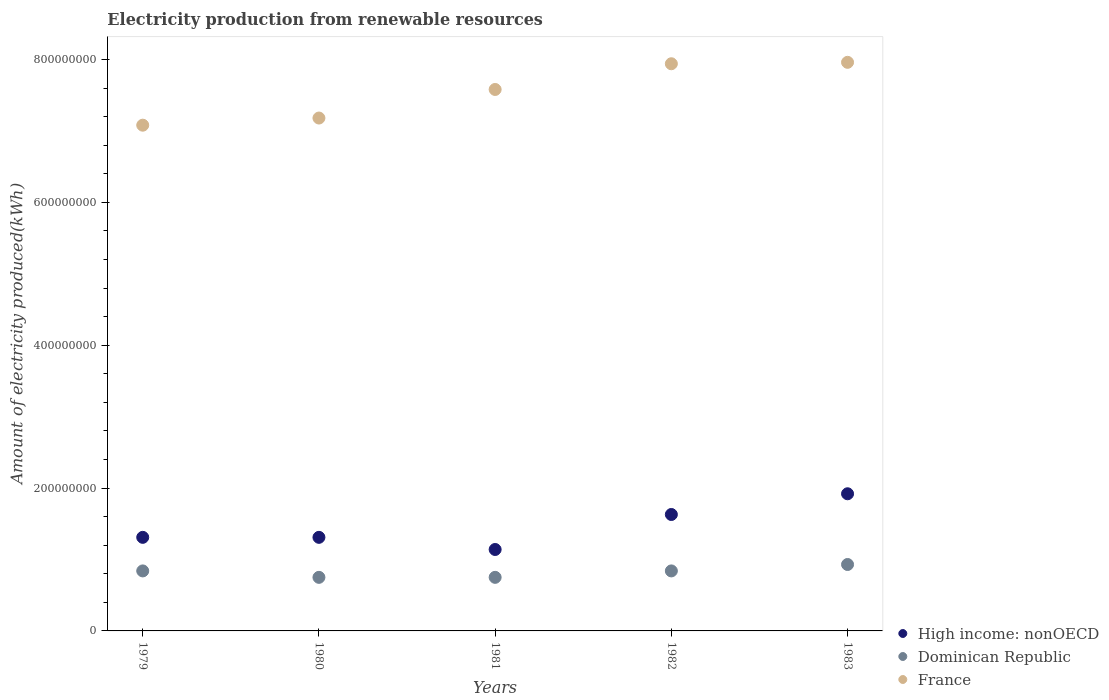How many different coloured dotlines are there?
Offer a terse response. 3. What is the amount of electricity produced in Dominican Republic in 1980?
Your answer should be compact. 7.50e+07. Across all years, what is the maximum amount of electricity produced in France?
Your response must be concise. 7.96e+08. Across all years, what is the minimum amount of electricity produced in High income: nonOECD?
Offer a terse response. 1.14e+08. In which year was the amount of electricity produced in Dominican Republic minimum?
Offer a terse response. 1980. What is the total amount of electricity produced in High income: nonOECD in the graph?
Ensure brevity in your answer.  7.31e+08. What is the difference between the amount of electricity produced in Dominican Republic in 1979 and that in 1981?
Your answer should be compact. 9.00e+06. What is the difference between the amount of electricity produced in Dominican Republic in 1979 and the amount of electricity produced in High income: nonOECD in 1982?
Give a very brief answer. -7.90e+07. What is the average amount of electricity produced in France per year?
Make the answer very short. 7.55e+08. In the year 1982, what is the difference between the amount of electricity produced in High income: nonOECD and amount of electricity produced in Dominican Republic?
Provide a short and direct response. 7.90e+07. What is the ratio of the amount of electricity produced in France in 1982 to that in 1983?
Offer a terse response. 1. Is the difference between the amount of electricity produced in High income: nonOECD in 1979 and 1980 greater than the difference between the amount of electricity produced in Dominican Republic in 1979 and 1980?
Make the answer very short. No. What is the difference between the highest and the second highest amount of electricity produced in Dominican Republic?
Give a very brief answer. 9.00e+06. What is the difference between the highest and the lowest amount of electricity produced in France?
Make the answer very short. 8.80e+07. In how many years, is the amount of electricity produced in Dominican Republic greater than the average amount of electricity produced in Dominican Republic taken over all years?
Give a very brief answer. 3. Is it the case that in every year, the sum of the amount of electricity produced in High income: nonOECD and amount of electricity produced in Dominican Republic  is greater than the amount of electricity produced in France?
Ensure brevity in your answer.  No. Is the amount of electricity produced in France strictly less than the amount of electricity produced in High income: nonOECD over the years?
Provide a succinct answer. No. How many years are there in the graph?
Give a very brief answer. 5. Are the values on the major ticks of Y-axis written in scientific E-notation?
Offer a terse response. No. Does the graph contain any zero values?
Your answer should be compact. No. Does the graph contain grids?
Offer a terse response. No. How are the legend labels stacked?
Ensure brevity in your answer.  Vertical. What is the title of the graph?
Ensure brevity in your answer.  Electricity production from renewable resources. What is the label or title of the X-axis?
Ensure brevity in your answer.  Years. What is the label or title of the Y-axis?
Provide a succinct answer. Amount of electricity produced(kWh). What is the Amount of electricity produced(kWh) of High income: nonOECD in 1979?
Your answer should be very brief. 1.31e+08. What is the Amount of electricity produced(kWh) of Dominican Republic in 1979?
Your answer should be compact. 8.40e+07. What is the Amount of electricity produced(kWh) in France in 1979?
Offer a very short reply. 7.08e+08. What is the Amount of electricity produced(kWh) of High income: nonOECD in 1980?
Offer a very short reply. 1.31e+08. What is the Amount of electricity produced(kWh) in Dominican Republic in 1980?
Make the answer very short. 7.50e+07. What is the Amount of electricity produced(kWh) of France in 1980?
Your answer should be very brief. 7.18e+08. What is the Amount of electricity produced(kWh) in High income: nonOECD in 1981?
Keep it short and to the point. 1.14e+08. What is the Amount of electricity produced(kWh) in Dominican Republic in 1981?
Ensure brevity in your answer.  7.50e+07. What is the Amount of electricity produced(kWh) of France in 1981?
Give a very brief answer. 7.58e+08. What is the Amount of electricity produced(kWh) in High income: nonOECD in 1982?
Ensure brevity in your answer.  1.63e+08. What is the Amount of electricity produced(kWh) of Dominican Republic in 1982?
Keep it short and to the point. 8.40e+07. What is the Amount of electricity produced(kWh) in France in 1982?
Make the answer very short. 7.94e+08. What is the Amount of electricity produced(kWh) in High income: nonOECD in 1983?
Offer a terse response. 1.92e+08. What is the Amount of electricity produced(kWh) in Dominican Republic in 1983?
Offer a very short reply. 9.30e+07. What is the Amount of electricity produced(kWh) in France in 1983?
Provide a short and direct response. 7.96e+08. Across all years, what is the maximum Amount of electricity produced(kWh) of High income: nonOECD?
Provide a succinct answer. 1.92e+08. Across all years, what is the maximum Amount of electricity produced(kWh) in Dominican Republic?
Offer a very short reply. 9.30e+07. Across all years, what is the maximum Amount of electricity produced(kWh) in France?
Keep it short and to the point. 7.96e+08. Across all years, what is the minimum Amount of electricity produced(kWh) of High income: nonOECD?
Provide a short and direct response. 1.14e+08. Across all years, what is the minimum Amount of electricity produced(kWh) in Dominican Republic?
Provide a short and direct response. 7.50e+07. Across all years, what is the minimum Amount of electricity produced(kWh) of France?
Provide a succinct answer. 7.08e+08. What is the total Amount of electricity produced(kWh) in High income: nonOECD in the graph?
Your answer should be compact. 7.31e+08. What is the total Amount of electricity produced(kWh) in Dominican Republic in the graph?
Your answer should be compact. 4.11e+08. What is the total Amount of electricity produced(kWh) in France in the graph?
Offer a very short reply. 3.77e+09. What is the difference between the Amount of electricity produced(kWh) in High income: nonOECD in 1979 and that in 1980?
Offer a terse response. 0. What is the difference between the Amount of electricity produced(kWh) of Dominican Republic in 1979 and that in 1980?
Make the answer very short. 9.00e+06. What is the difference between the Amount of electricity produced(kWh) of France in 1979 and that in 1980?
Ensure brevity in your answer.  -1.00e+07. What is the difference between the Amount of electricity produced(kWh) in High income: nonOECD in 1979 and that in 1981?
Give a very brief answer. 1.70e+07. What is the difference between the Amount of electricity produced(kWh) of Dominican Republic in 1979 and that in 1981?
Your answer should be very brief. 9.00e+06. What is the difference between the Amount of electricity produced(kWh) of France in 1979 and that in 1981?
Your answer should be compact. -5.00e+07. What is the difference between the Amount of electricity produced(kWh) of High income: nonOECD in 1979 and that in 1982?
Offer a terse response. -3.20e+07. What is the difference between the Amount of electricity produced(kWh) of Dominican Republic in 1979 and that in 1982?
Your response must be concise. 0. What is the difference between the Amount of electricity produced(kWh) in France in 1979 and that in 1982?
Your answer should be compact. -8.60e+07. What is the difference between the Amount of electricity produced(kWh) of High income: nonOECD in 1979 and that in 1983?
Ensure brevity in your answer.  -6.10e+07. What is the difference between the Amount of electricity produced(kWh) of Dominican Republic in 1979 and that in 1983?
Provide a succinct answer. -9.00e+06. What is the difference between the Amount of electricity produced(kWh) in France in 1979 and that in 1983?
Give a very brief answer. -8.80e+07. What is the difference between the Amount of electricity produced(kWh) of High income: nonOECD in 1980 and that in 1981?
Your response must be concise. 1.70e+07. What is the difference between the Amount of electricity produced(kWh) of France in 1980 and that in 1981?
Your answer should be compact. -4.00e+07. What is the difference between the Amount of electricity produced(kWh) in High income: nonOECD in 1980 and that in 1982?
Offer a terse response. -3.20e+07. What is the difference between the Amount of electricity produced(kWh) of Dominican Republic in 1980 and that in 1982?
Your response must be concise. -9.00e+06. What is the difference between the Amount of electricity produced(kWh) of France in 1980 and that in 1982?
Your answer should be compact. -7.60e+07. What is the difference between the Amount of electricity produced(kWh) in High income: nonOECD in 1980 and that in 1983?
Provide a short and direct response. -6.10e+07. What is the difference between the Amount of electricity produced(kWh) of Dominican Republic in 1980 and that in 1983?
Give a very brief answer. -1.80e+07. What is the difference between the Amount of electricity produced(kWh) in France in 1980 and that in 1983?
Provide a succinct answer. -7.80e+07. What is the difference between the Amount of electricity produced(kWh) in High income: nonOECD in 1981 and that in 1982?
Your answer should be very brief. -4.90e+07. What is the difference between the Amount of electricity produced(kWh) in Dominican Republic in 1981 and that in 1982?
Keep it short and to the point. -9.00e+06. What is the difference between the Amount of electricity produced(kWh) in France in 1981 and that in 1982?
Your answer should be compact. -3.60e+07. What is the difference between the Amount of electricity produced(kWh) of High income: nonOECD in 1981 and that in 1983?
Provide a short and direct response. -7.80e+07. What is the difference between the Amount of electricity produced(kWh) in Dominican Republic in 1981 and that in 1983?
Offer a very short reply. -1.80e+07. What is the difference between the Amount of electricity produced(kWh) in France in 1981 and that in 1983?
Provide a succinct answer. -3.80e+07. What is the difference between the Amount of electricity produced(kWh) in High income: nonOECD in 1982 and that in 1983?
Ensure brevity in your answer.  -2.90e+07. What is the difference between the Amount of electricity produced(kWh) of Dominican Republic in 1982 and that in 1983?
Offer a terse response. -9.00e+06. What is the difference between the Amount of electricity produced(kWh) of High income: nonOECD in 1979 and the Amount of electricity produced(kWh) of Dominican Republic in 1980?
Keep it short and to the point. 5.60e+07. What is the difference between the Amount of electricity produced(kWh) of High income: nonOECD in 1979 and the Amount of electricity produced(kWh) of France in 1980?
Make the answer very short. -5.87e+08. What is the difference between the Amount of electricity produced(kWh) of Dominican Republic in 1979 and the Amount of electricity produced(kWh) of France in 1980?
Keep it short and to the point. -6.34e+08. What is the difference between the Amount of electricity produced(kWh) of High income: nonOECD in 1979 and the Amount of electricity produced(kWh) of Dominican Republic in 1981?
Offer a very short reply. 5.60e+07. What is the difference between the Amount of electricity produced(kWh) of High income: nonOECD in 1979 and the Amount of electricity produced(kWh) of France in 1981?
Offer a terse response. -6.27e+08. What is the difference between the Amount of electricity produced(kWh) in Dominican Republic in 1979 and the Amount of electricity produced(kWh) in France in 1981?
Your answer should be compact. -6.74e+08. What is the difference between the Amount of electricity produced(kWh) in High income: nonOECD in 1979 and the Amount of electricity produced(kWh) in Dominican Republic in 1982?
Offer a terse response. 4.70e+07. What is the difference between the Amount of electricity produced(kWh) in High income: nonOECD in 1979 and the Amount of electricity produced(kWh) in France in 1982?
Provide a short and direct response. -6.63e+08. What is the difference between the Amount of electricity produced(kWh) in Dominican Republic in 1979 and the Amount of electricity produced(kWh) in France in 1982?
Ensure brevity in your answer.  -7.10e+08. What is the difference between the Amount of electricity produced(kWh) in High income: nonOECD in 1979 and the Amount of electricity produced(kWh) in Dominican Republic in 1983?
Your answer should be very brief. 3.80e+07. What is the difference between the Amount of electricity produced(kWh) of High income: nonOECD in 1979 and the Amount of electricity produced(kWh) of France in 1983?
Keep it short and to the point. -6.65e+08. What is the difference between the Amount of electricity produced(kWh) in Dominican Republic in 1979 and the Amount of electricity produced(kWh) in France in 1983?
Offer a very short reply. -7.12e+08. What is the difference between the Amount of electricity produced(kWh) in High income: nonOECD in 1980 and the Amount of electricity produced(kWh) in Dominican Republic in 1981?
Your answer should be very brief. 5.60e+07. What is the difference between the Amount of electricity produced(kWh) of High income: nonOECD in 1980 and the Amount of electricity produced(kWh) of France in 1981?
Offer a very short reply. -6.27e+08. What is the difference between the Amount of electricity produced(kWh) of Dominican Republic in 1980 and the Amount of electricity produced(kWh) of France in 1981?
Your answer should be very brief. -6.83e+08. What is the difference between the Amount of electricity produced(kWh) in High income: nonOECD in 1980 and the Amount of electricity produced(kWh) in Dominican Republic in 1982?
Provide a succinct answer. 4.70e+07. What is the difference between the Amount of electricity produced(kWh) in High income: nonOECD in 1980 and the Amount of electricity produced(kWh) in France in 1982?
Your response must be concise. -6.63e+08. What is the difference between the Amount of electricity produced(kWh) of Dominican Republic in 1980 and the Amount of electricity produced(kWh) of France in 1982?
Your answer should be compact. -7.19e+08. What is the difference between the Amount of electricity produced(kWh) of High income: nonOECD in 1980 and the Amount of electricity produced(kWh) of Dominican Republic in 1983?
Give a very brief answer. 3.80e+07. What is the difference between the Amount of electricity produced(kWh) of High income: nonOECD in 1980 and the Amount of electricity produced(kWh) of France in 1983?
Your answer should be very brief. -6.65e+08. What is the difference between the Amount of electricity produced(kWh) of Dominican Republic in 1980 and the Amount of electricity produced(kWh) of France in 1983?
Provide a short and direct response. -7.21e+08. What is the difference between the Amount of electricity produced(kWh) in High income: nonOECD in 1981 and the Amount of electricity produced(kWh) in Dominican Republic in 1982?
Make the answer very short. 3.00e+07. What is the difference between the Amount of electricity produced(kWh) of High income: nonOECD in 1981 and the Amount of electricity produced(kWh) of France in 1982?
Ensure brevity in your answer.  -6.80e+08. What is the difference between the Amount of electricity produced(kWh) in Dominican Republic in 1981 and the Amount of electricity produced(kWh) in France in 1982?
Offer a terse response. -7.19e+08. What is the difference between the Amount of electricity produced(kWh) of High income: nonOECD in 1981 and the Amount of electricity produced(kWh) of Dominican Republic in 1983?
Your response must be concise. 2.10e+07. What is the difference between the Amount of electricity produced(kWh) of High income: nonOECD in 1981 and the Amount of electricity produced(kWh) of France in 1983?
Your answer should be very brief. -6.82e+08. What is the difference between the Amount of electricity produced(kWh) of Dominican Republic in 1981 and the Amount of electricity produced(kWh) of France in 1983?
Ensure brevity in your answer.  -7.21e+08. What is the difference between the Amount of electricity produced(kWh) in High income: nonOECD in 1982 and the Amount of electricity produced(kWh) in Dominican Republic in 1983?
Your answer should be very brief. 7.00e+07. What is the difference between the Amount of electricity produced(kWh) of High income: nonOECD in 1982 and the Amount of electricity produced(kWh) of France in 1983?
Offer a very short reply. -6.33e+08. What is the difference between the Amount of electricity produced(kWh) of Dominican Republic in 1982 and the Amount of electricity produced(kWh) of France in 1983?
Ensure brevity in your answer.  -7.12e+08. What is the average Amount of electricity produced(kWh) of High income: nonOECD per year?
Your answer should be very brief. 1.46e+08. What is the average Amount of electricity produced(kWh) in Dominican Republic per year?
Ensure brevity in your answer.  8.22e+07. What is the average Amount of electricity produced(kWh) of France per year?
Provide a short and direct response. 7.55e+08. In the year 1979, what is the difference between the Amount of electricity produced(kWh) in High income: nonOECD and Amount of electricity produced(kWh) in Dominican Republic?
Ensure brevity in your answer.  4.70e+07. In the year 1979, what is the difference between the Amount of electricity produced(kWh) in High income: nonOECD and Amount of electricity produced(kWh) in France?
Keep it short and to the point. -5.77e+08. In the year 1979, what is the difference between the Amount of electricity produced(kWh) in Dominican Republic and Amount of electricity produced(kWh) in France?
Offer a very short reply. -6.24e+08. In the year 1980, what is the difference between the Amount of electricity produced(kWh) in High income: nonOECD and Amount of electricity produced(kWh) in Dominican Republic?
Offer a very short reply. 5.60e+07. In the year 1980, what is the difference between the Amount of electricity produced(kWh) of High income: nonOECD and Amount of electricity produced(kWh) of France?
Your answer should be very brief. -5.87e+08. In the year 1980, what is the difference between the Amount of electricity produced(kWh) in Dominican Republic and Amount of electricity produced(kWh) in France?
Make the answer very short. -6.43e+08. In the year 1981, what is the difference between the Amount of electricity produced(kWh) in High income: nonOECD and Amount of electricity produced(kWh) in Dominican Republic?
Ensure brevity in your answer.  3.90e+07. In the year 1981, what is the difference between the Amount of electricity produced(kWh) in High income: nonOECD and Amount of electricity produced(kWh) in France?
Provide a short and direct response. -6.44e+08. In the year 1981, what is the difference between the Amount of electricity produced(kWh) in Dominican Republic and Amount of electricity produced(kWh) in France?
Provide a short and direct response. -6.83e+08. In the year 1982, what is the difference between the Amount of electricity produced(kWh) in High income: nonOECD and Amount of electricity produced(kWh) in Dominican Republic?
Give a very brief answer. 7.90e+07. In the year 1982, what is the difference between the Amount of electricity produced(kWh) in High income: nonOECD and Amount of electricity produced(kWh) in France?
Offer a very short reply. -6.31e+08. In the year 1982, what is the difference between the Amount of electricity produced(kWh) of Dominican Republic and Amount of electricity produced(kWh) of France?
Keep it short and to the point. -7.10e+08. In the year 1983, what is the difference between the Amount of electricity produced(kWh) of High income: nonOECD and Amount of electricity produced(kWh) of Dominican Republic?
Make the answer very short. 9.90e+07. In the year 1983, what is the difference between the Amount of electricity produced(kWh) of High income: nonOECD and Amount of electricity produced(kWh) of France?
Your response must be concise. -6.04e+08. In the year 1983, what is the difference between the Amount of electricity produced(kWh) in Dominican Republic and Amount of electricity produced(kWh) in France?
Your answer should be very brief. -7.03e+08. What is the ratio of the Amount of electricity produced(kWh) in Dominican Republic in 1979 to that in 1980?
Keep it short and to the point. 1.12. What is the ratio of the Amount of electricity produced(kWh) in France in 1979 to that in 1980?
Provide a short and direct response. 0.99. What is the ratio of the Amount of electricity produced(kWh) of High income: nonOECD in 1979 to that in 1981?
Give a very brief answer. 1.15. What is the ratio of the Amount of electricity produced(kWh) in Dominican Republic in 1979 to that in 1981?
Provide a short and direct response. 1.12. What is the ratio of the Amount of electricity produced(kWh) in France in 1979 to that in 1981?
Your answer should be compact. 0.93. What is the ratio of the Amount of electricity produced(kWh) of High income: nonOECD in 1979 to that in 1982?
Ensure brevity in your answer.  0.8. What is the ratio of the Amount of electricity produced(kWh) in Dominican Republic in 1979 to that in 1982?
Give a very brief answer. 1. What is the ratio of the Amount of electricity produced(kWh) in France in 1979 to that in 1982?
Give a very brief answer. 0.89. What is the ratio of the Amount of electricity produced(kWh) in High income: nonOECD in 1979 to that in 1983?
Provide a short and direct response. 0.68. What is the ratio of the Amount of electricity produced(kWh) of Dominican Republic in 1979 to that in 1983?
Provide a short and direct response. 0.9. What is the ratio of the Amount of electricity produced(kWh) of France in 1979 to that in 1983?
Offer a terse response. 0.89. What is the ratio of the Amount of electricity produced(kWh) in High income: nonOECD in 1980 to that in 1981?
Your answer should be compact. 1.15. What is the ratio of the Amount of electricity produced(kWh) of Dominican Republic in 1980 to that in 1981?
Offer a terse response. 1. What is the ratio of the Amount of electricity produced(kWh) of France in 1980 to that in 1981?
Provide a succinct answer. 0.95. What is the ratio of the Amount of electricity produced(kWh) of High income: nonOECD in 1980 to that in 1982?
Make the answer very short. 0.8. What is the ratio of the Amount of electricity produced(kWh) in Dominican Republic in 1980 to that in 1982?
Provide a succinct answer. 0.89. What is the ratio of the Amount of electricity produced(kWh) in France in 1980 to that in 1982?
Ensure brevity in your answer.  0.9. What is the ratio of the Amount of electricity produced(kWh) in High income: nonOECD in 1980 to that in 1983?
Offer a very short reply. 0.68. What is the ratio of the Amount of electricity produced(kWh) in Dominican Republic in 1980 to that in 1983?
Provide a succinct answer. 0.81. What is the ratio of the Amount of electricity produced(kWh) of France in 1980 to that in 1983?
Keep it short and to the point. 0.9. What is the ratio of the Amount of electricity produced(kWh) of High income: nonOECD in 1981 to that in 1982?
Your answer should be very brief. 0.7. What is the ratio of the Amount of electricity produced(kWh) of Dominican Republic in 1981 to that in 1982?
Your response must be concise. 0.89. What is the ratio of the Amount of electricity produced(kWh) in France in 1981 to that in 1982?
Give a very brief answer. 0.95. What is the ratio of the Amount of electricity produced(kWh) in High income: nonOECD in 1981 to that in 1983?
Make the answer very short. 0.59. What is the ratio of the Amount of electricity produced(kWh) of Dominican Republic in 1981 to that in 1983?
Make the answer very short. 0.81. What is the ratio of the Amount of electricity produced(kWh) of France in 1981 to that in 1983?
Your answer should be very brief. 0.95. What is the ratio of the Amount of electricity produced(kWh) in High income: nonOECD in 1982 to that in 1983?
Offer a very short reply. 0.85. What is the ratio of the Amount of electricity produced(kWh) in Dominican Republic in 1982 to that in 1983?
Offer a very short reply. 0.9. What is the ratio of the Amount of electricity produced(kWh) of France in 1982 to that in 1983?
Provide a succinct answer. 1. What is the difference between the highest and the second highest Amount of electricity produced(kWh) of High income: nonOECD?
Offer a very short reply. 2.90e+07. What is the difference between the highest and the second highest Amount of electricity produced(kWh) of Dominican Republic?
Your answer should be compact. 9.00e+06. What is the difference between the highest and the lowest Amount of electricity produced(kWh) of High income: nonOECD?
Your answer should be very brief. 7.80e+07. What is the difference between the highest and the lowest Amount of electricity produced(kWh) in Dominican Republic?
Your answer should be compact. 1.80e+07. What is the difference between the highest and the lowest Amount of electricity produced(kWh) of France?
Ensure brevity in your answer.  8.80e+07. 